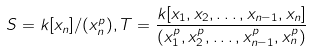Convert formula to latex. <formula><loc_0><loc_0><loc_500><loc_500>S = k [ x _ { n } ] / ( x _ { n } ^ { p } ) , T = \frac { k [ x _ { 1 } , x _ { 2 } , \dots , x _ { n - 1 } , x _ { n } ] } { ( x _ { 1 } ^ { p } , x _ { 2 } ^ { p } , \dots , x _ { n - 1 } ^ { p } , x _ { n } ^ { p } ) }</formula> 